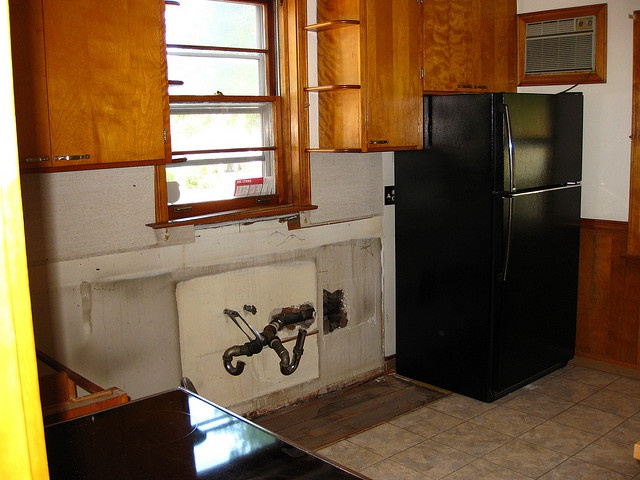Describe the objects in this image and their specific colors. I can see refrigerator in white, black, darkgreen, and gray tones and oven in white, black, gray, and lightblue tones in this image. 